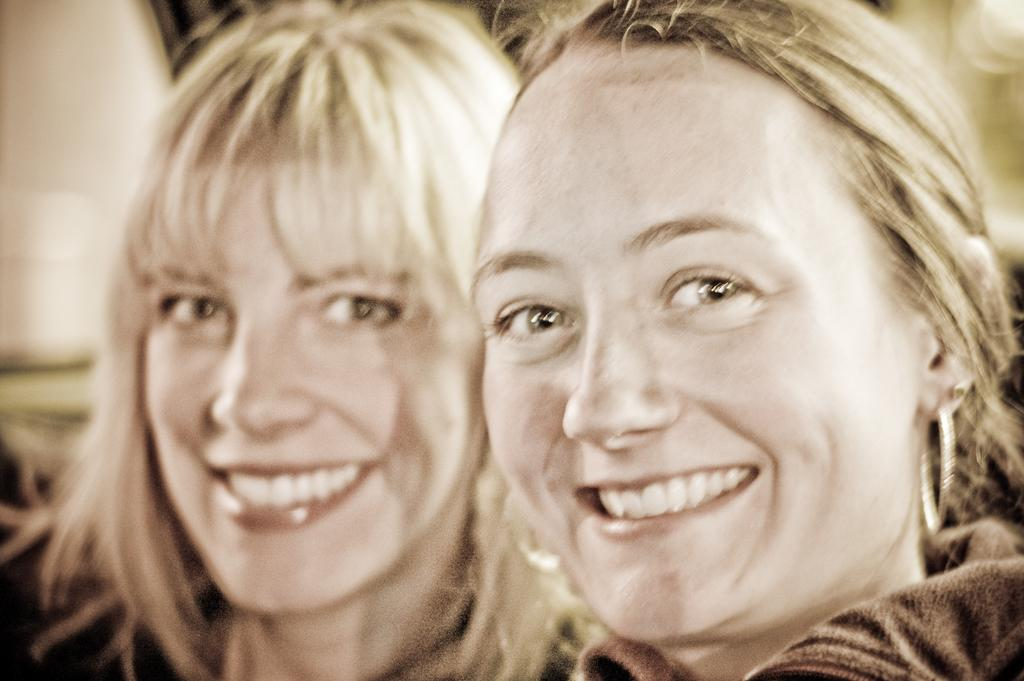How many people are in the image? There are two women in the image. What is the facial expression of the women? The women have smiling faces. Can you describe the object on the top left side of the image? There is a white object on the top left side of the image. What is the condition of the background in the image? The background of the image is blurred. What type of pear is being used to create friction on the table in the image? There is no pear or table present in the image, and therefore no such activity can be observed. 